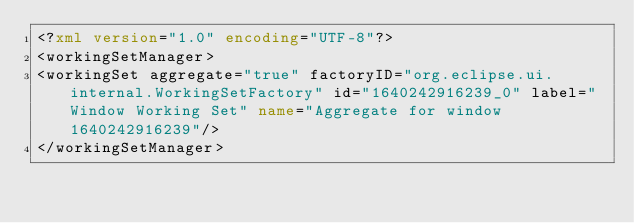<code> <loc_0><loc_0><loc_500><loc_500><_XML_><?xml version="1.0" encoding="UTF-8"?>
<workingSetManager>
<workingSet aggregate="true" factoryID="org.eclipse.ui.internal.WorkingSetFactory" id="1640242916239_0" label="Window Working Set" name="Aggregate for window 1640242916239"/>
</workingSetManager></code> 